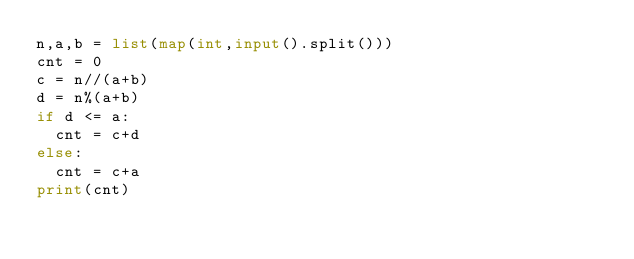<code> <loc_0><loc_0><loc_500><loc_500><_Python_>n,a,b = list(map(int,input().split()))
cnt = 0
c = n//(a+b)
d = n%(a+b)
if d <= a:
  cnt = c+d
else:
  cnt = c+a
print(cnt)</code> 